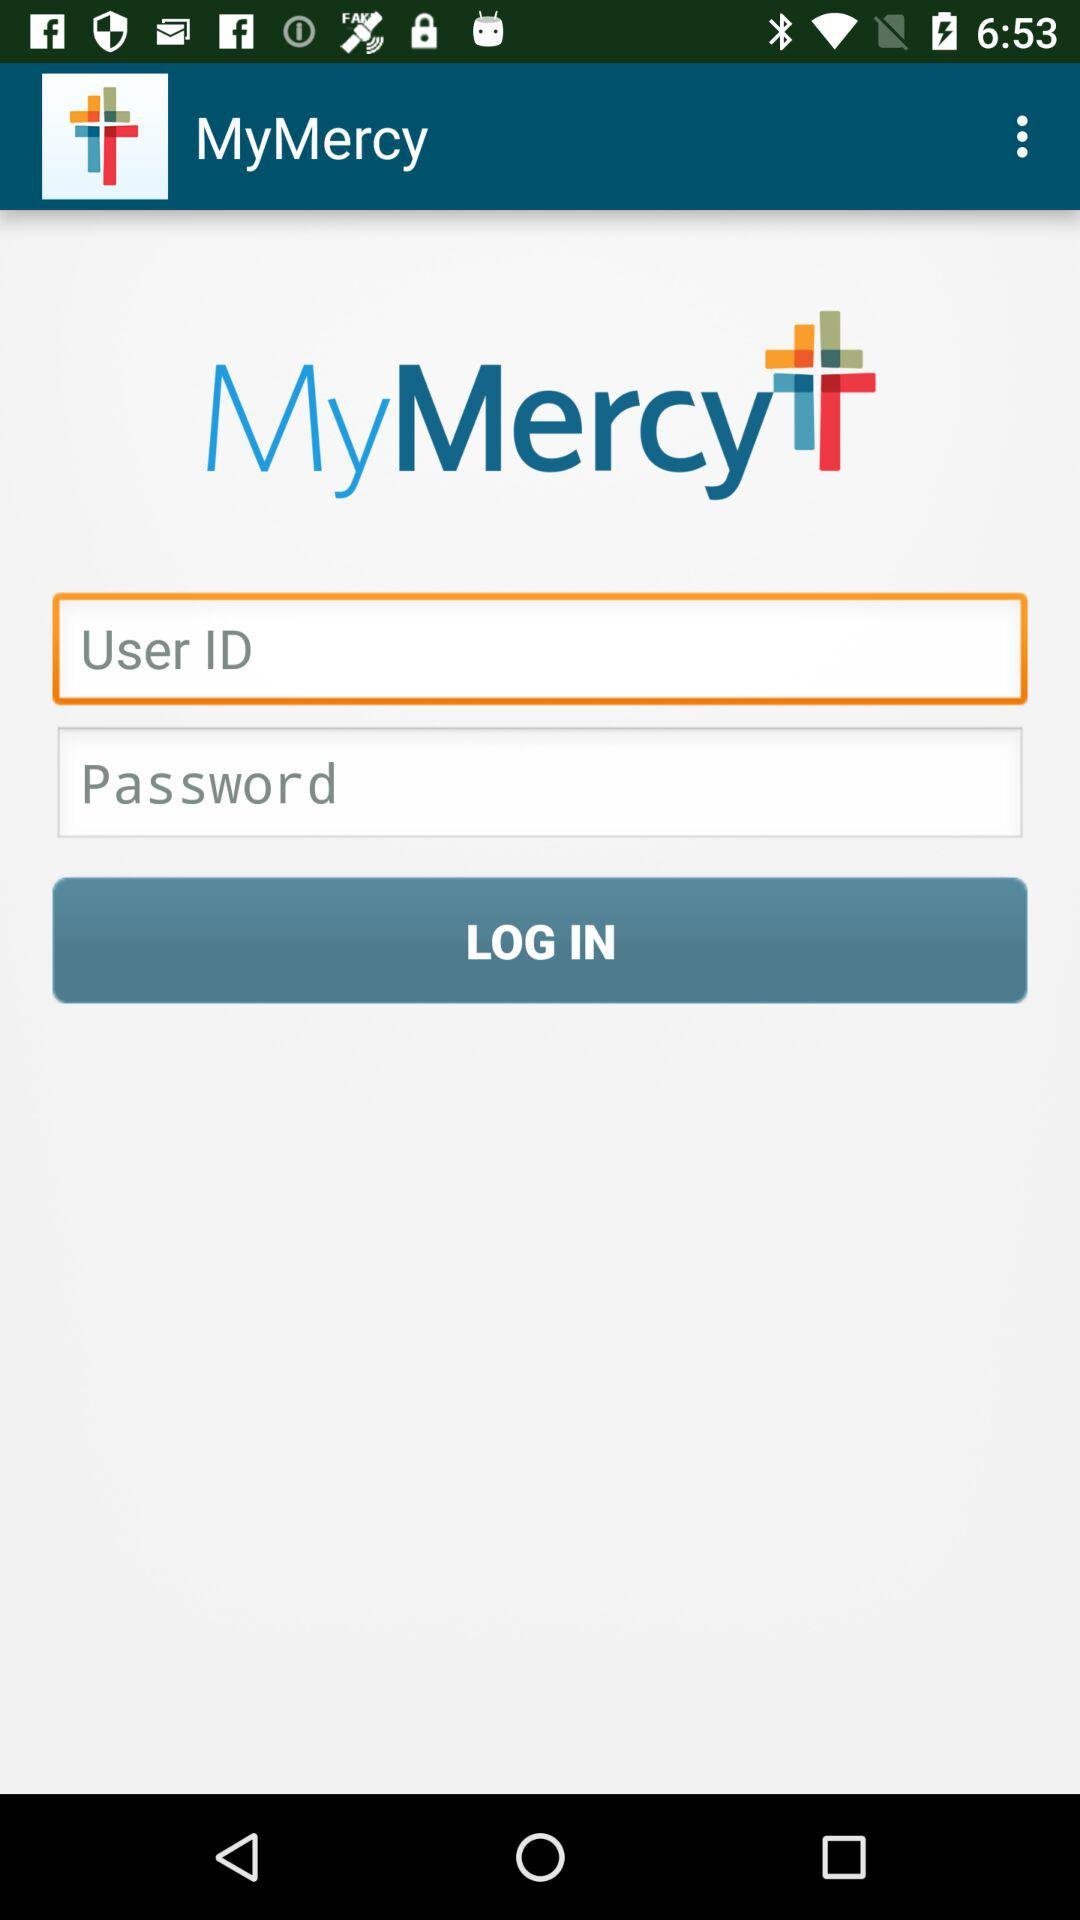What is the application name? The application name is "MyMercy". 